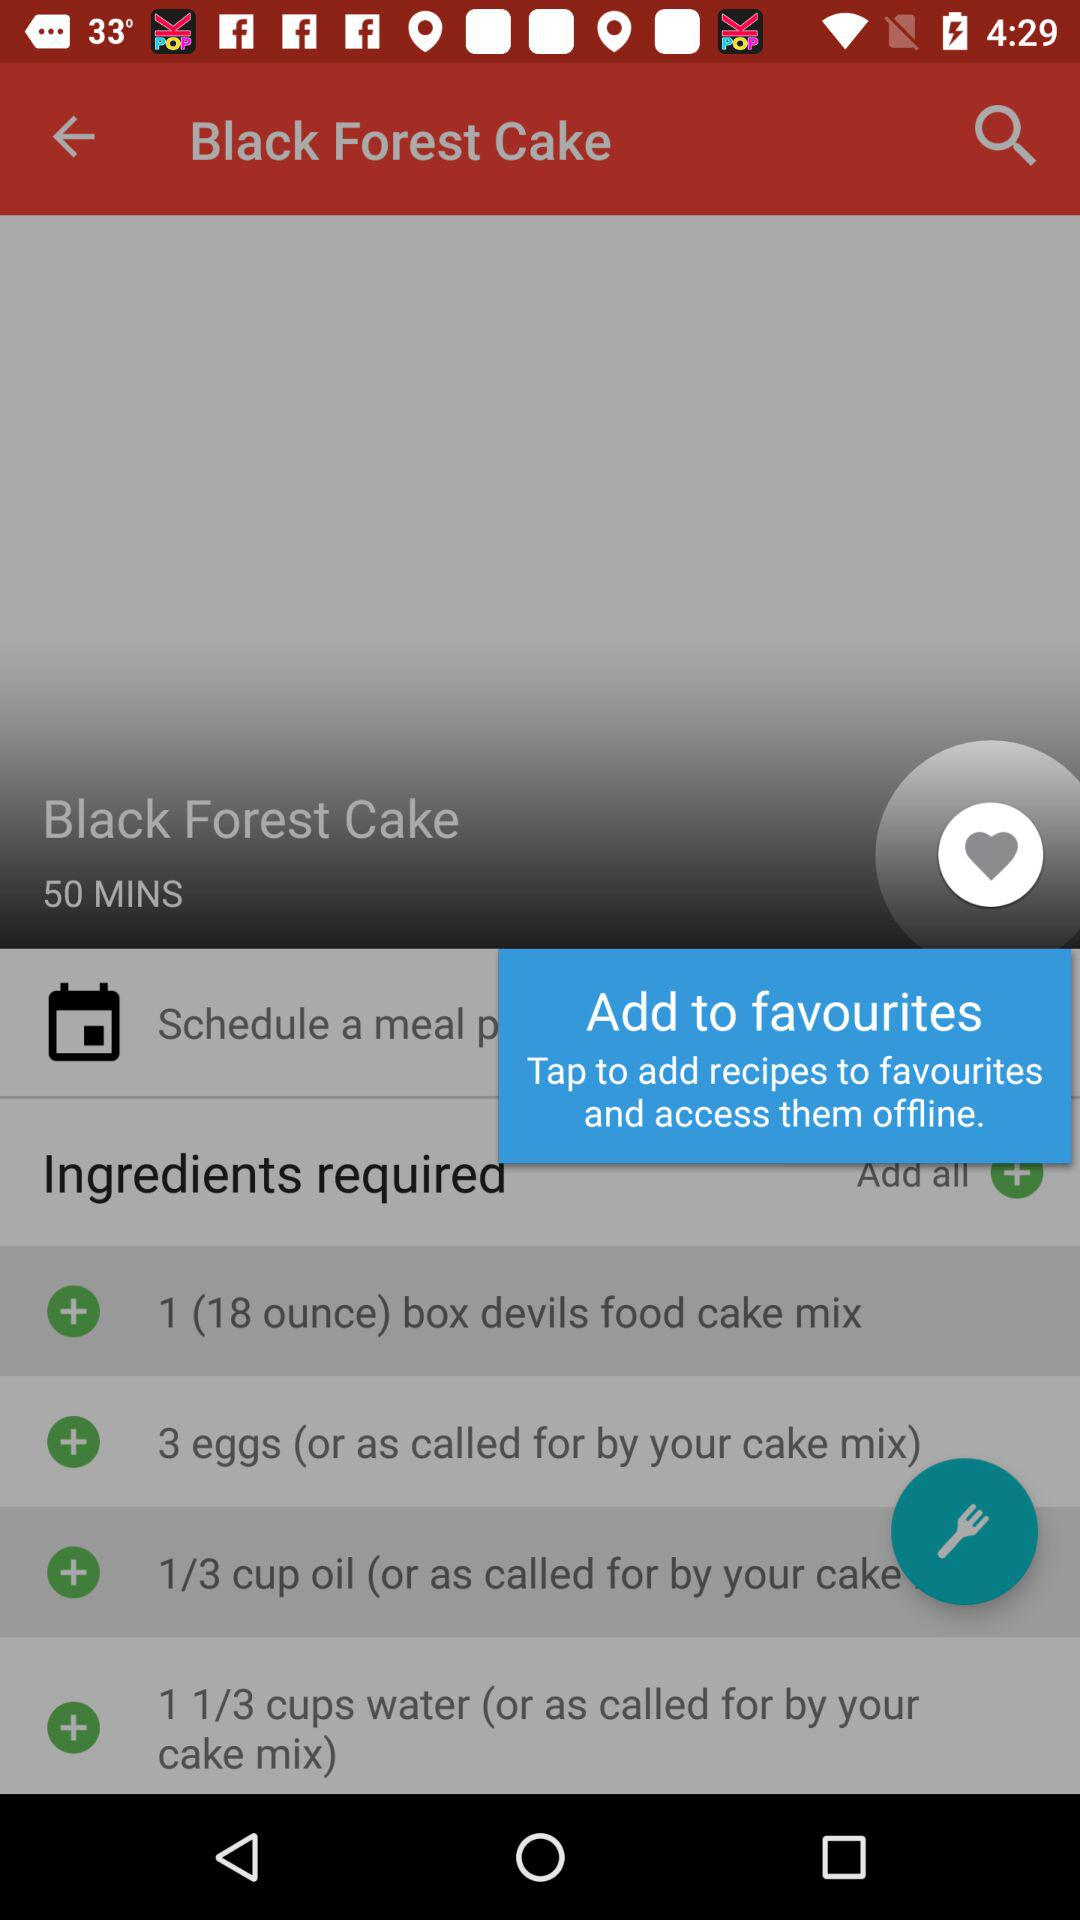How much time does it take to make the "Black Forest Cake"? It takes 50 minutes to make the "Black Forest Cake". 